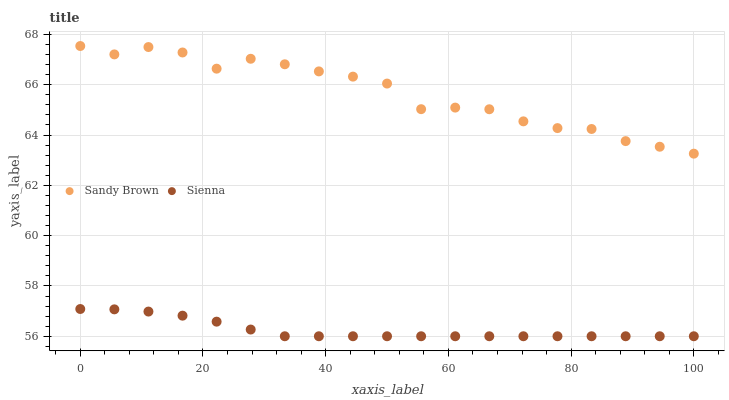Does Sienna have the minimum area under the curve?
Answer yes or no. Yes. Does Sandy Brown have the maximum area under the curve?
Answer yes or no. Yes. Does Sandy Brown have the minimum area under the curve?
Answer yes or no. No. Is Sienna the smoothest?
Answer yes or no. Yes. Is Sandy Brown the roughest?
Answer yes or no. Yes. Is Sandy Brown the smoothest?
Answer yes or no. No. Does Sienna have the lowest value?
Answer yes or no. Yes. Does Sandy Brown have the lowest value?
Answer yes or no. No. Does Sandy Brown have the highest value?
Answer yes or no. Yes. Is Sienna less than Sandy Brown?
Answer yes or no. Yes. Is Sandy Brown greater than Sienna?
Answer yes or no. Yes. Does Sienna intersect Sandy Brown?
Answer yes or no. No. 